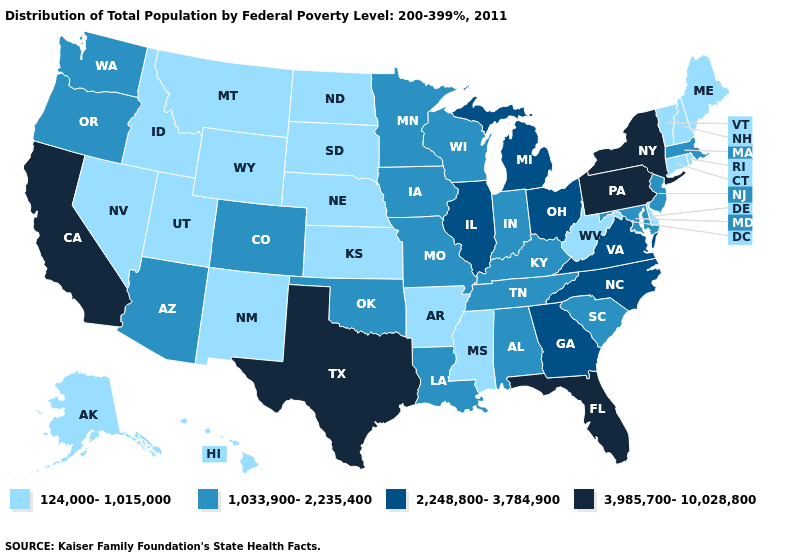What is the lowest value in the Northeast?
Keep it brief. 124,000-1,015,000. Does Arkansas have the lowest value in the South?
Be succinct. Yes. Name the states that have a value in the range 2,248,800-3,784,900?
Concise answer only. Georgia, Illinois, Michigan, North Carolina, Ohio, Virginia. What is the lowest value in states that border Oregon?
Quick response, please. 124,000-1,015,000. What is the lowest value in the USA?
Quick response, please. 124,000-1,015,000. Among the states that border Arizona , does Utah have the highest value?
Concise answer only. No. Is the legend a continuous bar?
Be succinct. No. Name the states that have a value in the range 124,000-1,015,000?
Write a very short answer. Alaska, Arkansas, Connecticut, Delaware, Hawaii, Idaho, Kansas, Maine, Mississippi, Montana, Nebraska, Nevada, New Hampshire, New Mexico, North Dakota, Rhode Island, South Dakota, Utah, Vermont, West Virginia, Wyoming. Name the states that have a value in the range 2,248,800-3,784,900?
Keep it brief. Georgia, Illinois, Michigan, North Carolina, Ohio, Virginia. Does California have the highest value in the West?
Give a very brief answer. Yes. What is the value of Arkansas?
Quick response, please. 124,000-1,015,000. Name the states that have a value in the range 2,248,800-3,784,900?
Keep it brief. Georgia, Illinois, Michigan, North Carolina, Ohio, Virginia. Does the first symbol in the legend represent the smallest category?
Be succinct. Yes. How many symbols are there in the legend?
Short answer required. 4. What is the value of Delaware?
Be succinct. 124,000-1,015,000. 